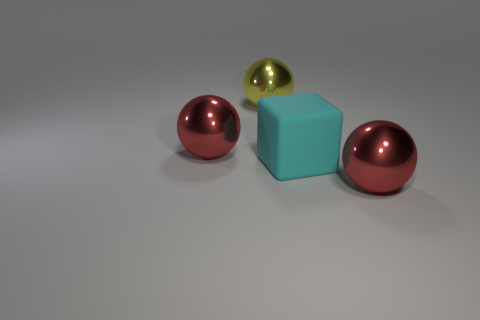Subtract all red shiny balls. How many balls are left? 1 Add 3 yellow balls. How many objects exist? 7 Subtract 1 blocks. How many blocks are left? 0 Subtract all yellow spheres. How many spheres are left? 2 Subtract 0 purple balls. How many objects are left? 4 Subtract all blocks. How many objects are left? 3 Subtract all blue blocks. Subtract all purple spheres. How many blocks are left? 1 Subtract all yellow cylinders. How many red spheres are left? 2 Subtract all big yellow metallic things. Subtract all big blue shiny cubes. How many objects are left? 3 Add 3 large cyan rubber blocks. How many large cyan rubber blocks are left? 4 